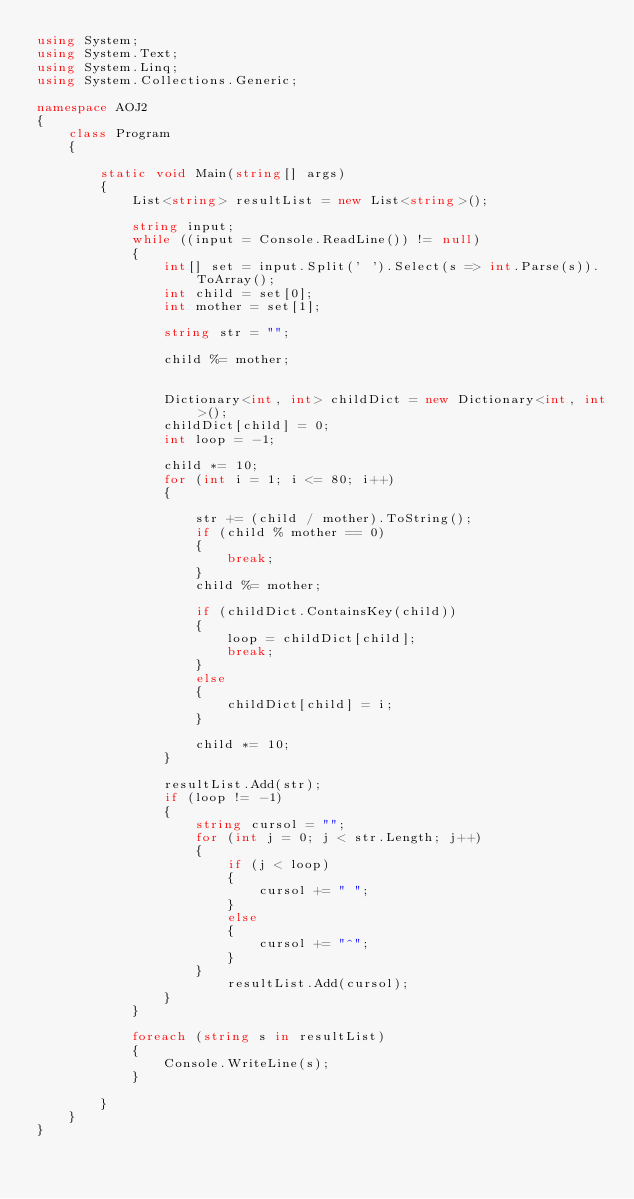Convert code to text. <code><loc_0><loc_0><loc_500><loc_500><_C#_>using System;
using System.Text;
using System.Linq;
using System.Collections.Generic;

namespace AOJ2
{
    class Program
    {

        static void Main(string[] args)
        {
            List<string> resultList = new List<string>();

            string input;
            while ((input = Console.ReadLine()) != null)
            {
                int[] set = input.Split(' ').Select(s => int.Parse(s)).ToArray();
                int child = set[0];
                int mother = set[1];

                string str = "";

                child %= mother;
                
               
                Dictionary<int, int> childDict = new Dictionary<int, int>();
                childDict[child] = 0;
                int loop = -1;

                child *= 10;
                for (int i = 1; i <= 80; i++)
                {

                    str += (child / mother).ToString();
                    if (child % mother == 0)
                    {
                        break;
                    }
                    child %= mother;
                    
                    if (childDict.ContainsKey(child))
                    {
                        loop = childDict[child];
                        break;
                    }
                    else
                    {
                        childDict[child] = i;
                    }

                    child *= 10;
                }

                resultList.Add(str);
                if (loop != -1)
                {
                    string cursol = "";
                    for (int j = 0; j < str.Length; j++)
                    {
                        if (j < loop)
                        {
                            cursol += " ";
                        }
                        else
                        {
                            cursol += "^";
                        }
                    }
                        resultList.Add(cursol);
                }
            }

            foreach (string s in resultList)
            {
                Console.WriteLine(s);
            }

        }
    }
}</code> 